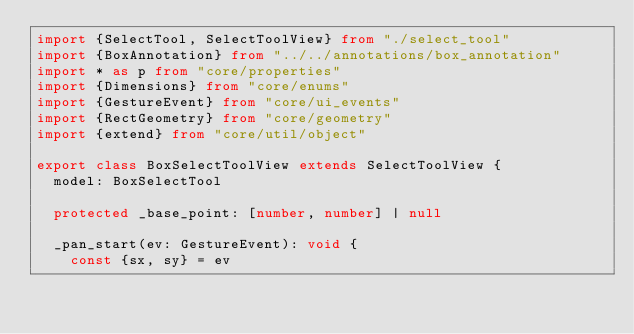Convert code to text. <code><loc_0><loc_0><loc_500><loc_500><_TypeScript_>import {SelectTool, SelectToolView} from "./select_tool"
import {BoxAnnotation} from "../../annotations/box_annotation"
import * as p from "core/properties"
import {Dimensions} from "core/enums"
import {GestureEvent} from "core/ui_events"
import {RectGeometry} from "core/geometry"
import {extend} from "core/util/object"

export class BoxSelectToolView extends SelectToolView {
  model: BoxSelectTool

  protected _base_point: [number, number] | null

  _pan_start(ev: GestureEvent): void {
    const {sx, sy} = ev</code> 